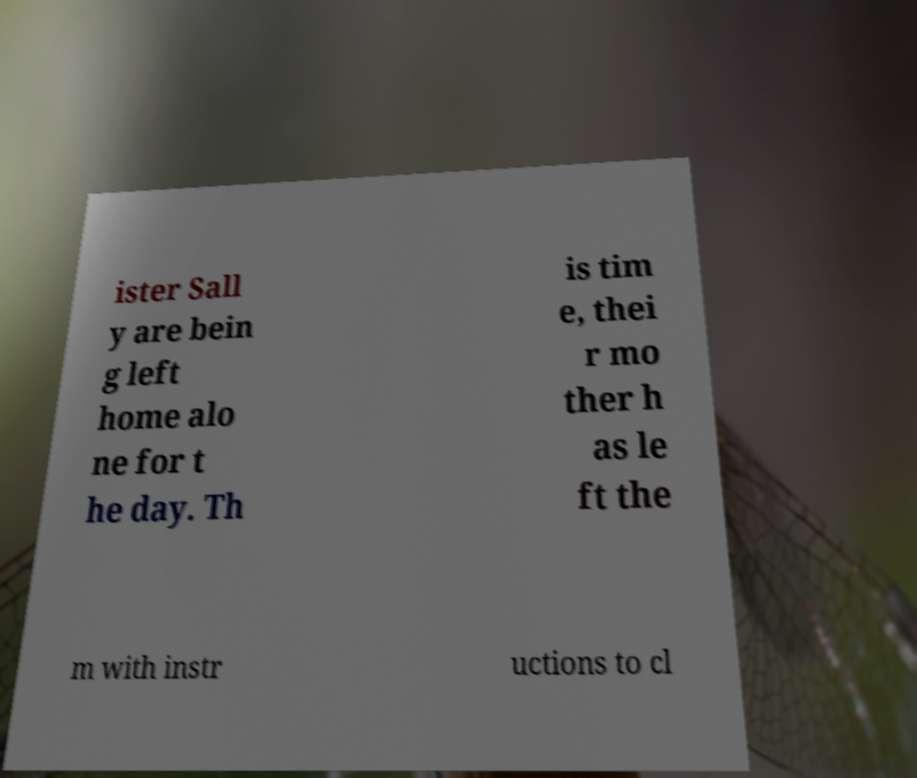Please identify and transcribe the text found in this image. ister Sall y are bein g left home alo ne for t he day. Th is tim e, thei r mo ther h as le ft the m with instr uctions to cl 